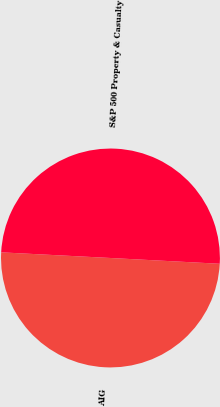Convert chart to OTSL. <chart><loc_0><loc_0><loc_500><loc_500><pie_chart><fcel>AIG<fcel>S&P 500 Property & Casualty<nl><fcel>49.98%<fcel>50.02%<nl></chart> 